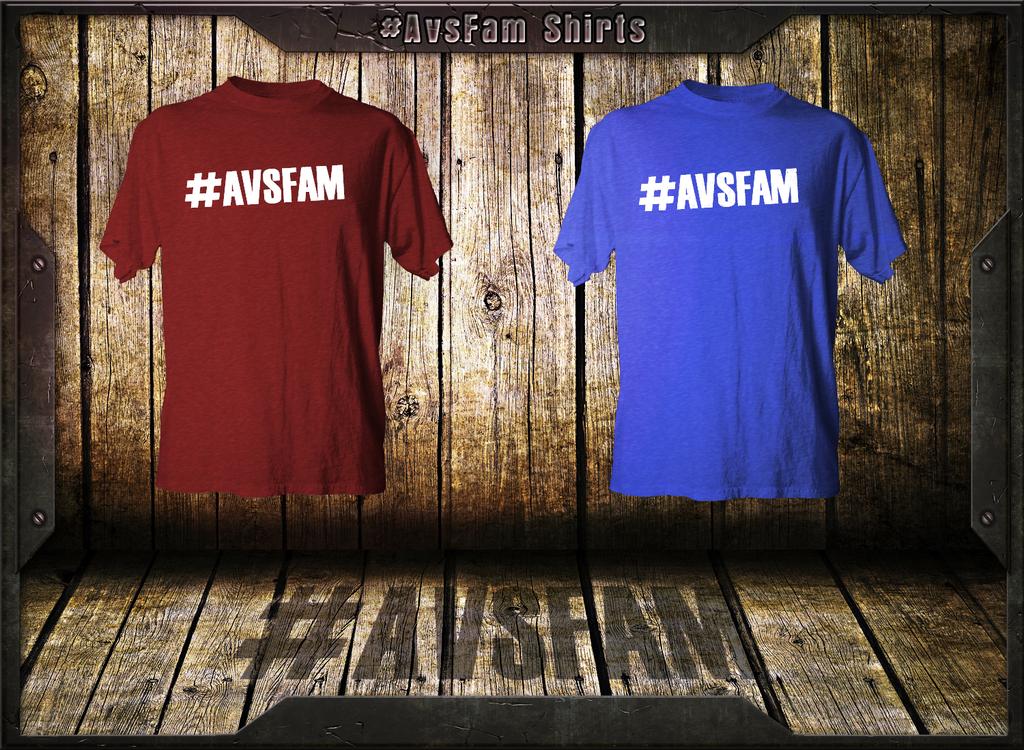What are the # word?
Your answer should be compact. Avsfam. 